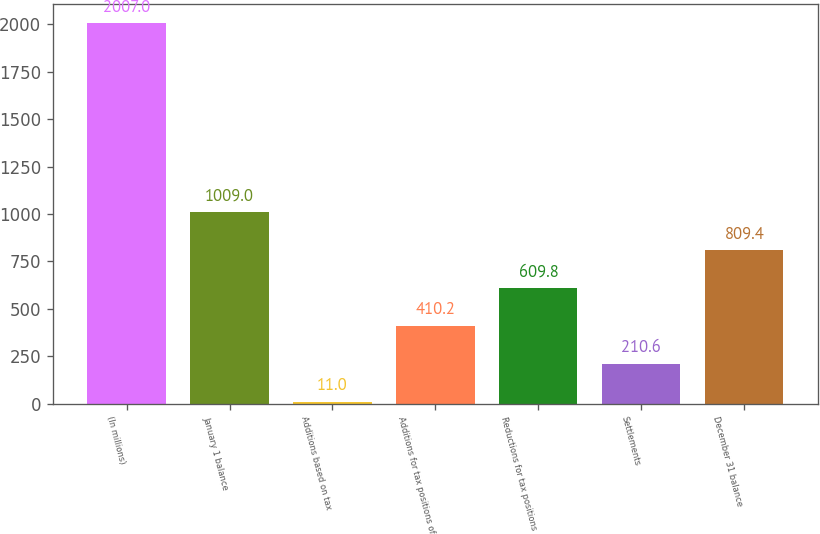Convert chart to OTSL. <chart><loc_0><loc_0><loc_500><loc_500><bar_chart><fcel>(In millions)<fcel>January 1 balance<fcel>Additions based on tax<fcel>Additions for tax positions of<fcel>Reductions for tax positions<fcel>Settlements<fcel>December 31 balance<nl><fcel>2007<fcel>1009<fcel>11<fcel>410.2<fcel>609.8<fcel>210.6<fcel>809.4<nl></chart> 